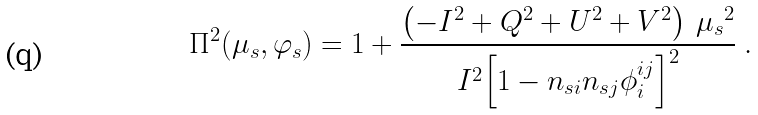Convert formula to latex. <formula><loc_0><loc_0><loc_500><loc_500>\Pi ^ { 2 } ( \mu _ { s } , \varphi _ { s } ) = 1 + \frac { \left ( - I ^ { 2 } + Q ^ { 2 } + U ^ { 2 } + V ^ { 2 } \right ) \, { \mu _ { s } } ^ { 2 } } { I ^ { 2 } { \left [ 1 - n _ { s i } n _ { s j } \phi _ { i } ^ { i j } \right ] } ^ { 2 } } \ .</formula> 